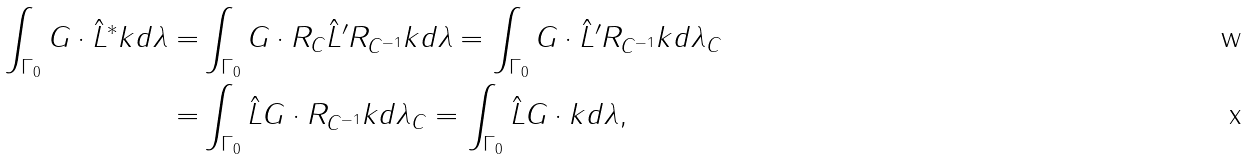<formula> <loc_0><loc_0><loc_500><loc_500>\int _ { \Gamma _ { 0 } } G \cdot { \hat { L } } ^ { \ast } k d \lambda = & \int _ { \Gamma _ { 0 } } G \cdot R _ { C } { \hat { L } } ^ { \prime } R _ { C ^ { - 1 } } k d \lambda = \int _ { \Gamma _ { 0 } } G \cdot { \hat { L } } ^ { \prime } R _ { C ^ { - 1 } } k d \lambda _ { C } \\ = & \int _ { \Gamma _ { 0 } } { \hat { L } } G \cdot R _ { C ^ { - 1 } } k d \lambda _ { C } = \int _ { \Gamma _ { 0 } } { \hat { L } } G \cdot k d \lambda ,</formula> 